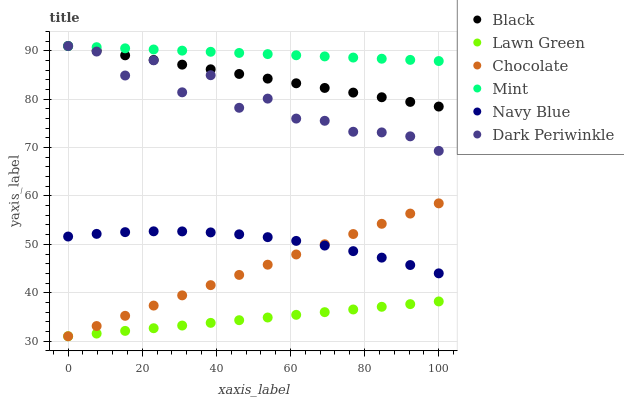Does Lawn Green have the minimum area under the curve?
Answer yes or no. Yes. Does Mint have the maximum area under the curve?
Answer yes or no. Yes. Does Navy Blue have the minimum area under the curve?
Answer yes or no. No. Does Navy Blue have the maximum area under the curve?
Answer yes or no. No. Is Chocolate the smoothest?
Answer yes or no. Yes. Is Dark Periwinkle the roughest?
Answer yes or no. Yes. Is Navy Blue the smoothest?
Answer yes or no. No. Is Navy Blue the roughest?
Answer yes or no. No. Does Lawn Green have the lowest value?
Answer yes or no. Yes. Does Navy Blue have the lowest value?
Answer yes or no. No. Does Dark Periwinkle have the highest value?
Answer yes or no. Yes. Does Navy Blue have the highest value?
Answer yes or no. No. Is Navy Blue less than Black?
Answer yes or no. Yes. Is Black greater than Navy Blue?
Answer yes or no. Yes. Does Chocolate intersect Navy Blue?
Answer yes or no. Yes. Is Chocolate less than Navy Blue?
Answer yes or no. No. Is Chocolate greater than Navy Blue?
Answer yes or no. No. Does Navy Blue intersect Black?
Answer yes or no. No. 